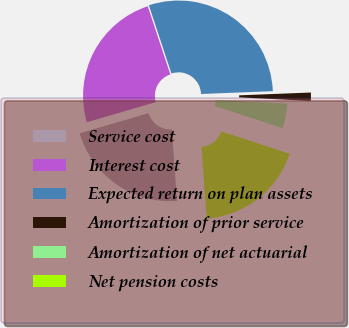Convert chart to OTSL. <chart><loc_0><loc_0><loc_500><loc_500><pie_chart><fcel>Service cost<fcel>Interest cost<fcel>Expected return on plan assets<fcel>Amortization of prior service<fcel>Amortization of net actuarial<fcel>Net pension costs<nl><fcel>21.62%<fcel>24.43%<fcel>29.46%<fcel>1.43%<fcel>4.24%<fcel>18.82%<nl></chart> 